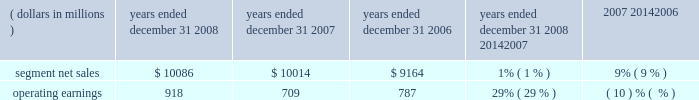Products and software , as well as ongoing investment in next-generation technologies , partially offset by savings from cost-reduction initiatives .
Reorganization of business charges increased due to employee severance costs and expenses related to the exit of a facility .
Sg&a expenses decreased , primarily due to lower marketing expenses and savings from cost-reduction initiatives , partially offset by increased expenditures on information technology upgrades .
As a percentage of net sales in 2007 as compared to 2006 , gross margin and operating margin decreased , and sg&a expenses and r&d expenditures increased .
The segment 2019s backlog was $ 647 million at december 31 , 2007 , compared to $ 1.4 billion at december 31 , 2006 .
This decrease in backlog was primarily due to a decline in customer demand driven by the segment 2019s limited product portfolio .
The segment shipped 159.1 million units in 2007 , a 27% ( 27 % ) decrease compared to shipments of 217.4 million units in 2006 .
The overall decrease reflects decreased unit shipments of products for all technologies .
For the full year 2007 , unit shipments : ( i ) decreased substantially in asia and emea , ( ii ) decreased in north america , and ( iii ) increased in latin america .
Although unit shipments by the segment decreased in 2007 , total unit shipments in the worldwide handset market increased by approximately 16% ( 16 % ) .
The segment estimates its worldwide market share was approximately 14% ( 14 % ) for the full year 2007 , a decrease of approximately 8 percentage points versus full year 2006 .
In 2007 , asp decreased approximately 9% ( 9 % ) compared to 2006 .
The overall decrease in asp was driven primarily by changes in the product-tier and geographic mix of sales .
By comparison , asp decreased approximately 11% ( 11 % ) in 2006 and 10% ( 10 % ) in 2005 .
The segment has several large customers located throughout the world .
In 2007 , aggregate net sales to the segment 2019s five largest customers accounted for approximately 42% ( 42 % ) of the segment 2019s net sales .
Besides selling directly to carriers and operators , the segment also sells products through a variety of third-party distributors and retailers , which account for approximately 33% ( 33 % ) of the segment 2019s net sales .
The largest of these distributors was brightstar corporation .
Although the u.s .
Market continued to be the segment 2019s largest individual market , many of our customers , and more than 54% ( 54 % ) of our segment 2019s 2007 net sales , were outside the u.s .
The largest of these international markets were brazil , china and mexico .
Home and networks mobility segment the home and networks mobility segment designs , manufactures , sells , installs and services : ( i ) digital video , internet protocol video and broadcast network interactive set-tops , end-to-end video delivery systems , broadband access infrastructure platforms , and associated data and voice customer premise equipment to cable television and telecom service providers ( collectively , referred to as the 201chome business 201d ) , and ( ii ) wireless access systems , including cellular infrastructure systems and wireless broadband systems , to wireless service providers ( collectively , referred to as the 201cnetwork business 201d ) .
In 2008 , the segment 2019s net sales represented 33% ( 33 % ) of the company 2019s consolidated net sales , compared to 27% ( 27 % ) in 2007 and 21% ( 21 % ) in 2006 .
( dollars in millions ) 2008 2007 2006 2008 20142007 2007 20142006 years ended december 31 percent change .
Segment results 20142008 compared to 2007 in 2008 , the segment 2019s net sales increased 1% ( 1 % ) to $ 10.1 billion , compared to $ 10.0 billion in 2007 .
The 1% ( 1 % ) increase in net sales primarily reflects a 16% ( 16 % ) increase in net sales in the home business , partially offset by an 11% ( 11 % ) decrease in net sales in the networks business .
The 16% ( 16 % ) increase in net sales in the home business is primarily driven by a 17% ( 17 % ) increase in net sales of digital entertainment devices , reflecting a 19% ( 19 % ) increase in unit shipments to 18.0 million units , partially offset by lower asp due to product mix shift and pricing pressure .
The 11% ( 11 % ) decrease in net sales in the networks business was primarily driven by : ( i ) the absence of net sales by the embedded communication computing group ( 201cecc 201d ) that was divested at the end of 2007 , and ( ii ) lower net sales of iden , gsm and cdma infrastructure equipment , partially offset by higher net sales of umts infrastructure equipment .
On a geographic basis , the 1% ( 1 % ) increase in net sales was primarily driven by higher net sales in latin america and asia , partially offset by lower net sales in north america .
The increase in net sales in latin america was 63management 2019s discussion and analysis of financial condition and results of operations %%transmsg*** transmitting job : c49054 pcn : 066000000 ***%%pcmsg|63 |00024|yes|no|02/24/2009 12:31|0|0|page is valid , no graphics -- color : n| .
What was the change in percentage of consolidated net sales from 2006 to 2008? 
Rationale: the consolidated net sales grew 72.95% from 2006 to 2008 . to get this answer you must find out the consolidated net sales which was given in line 23 . then you must take this consolidated net sales and subtract them from each other . take this answer and divide it by the consolidated net sales for 2006 .
Computations: (((10086 * 33%) - (9164 * 21%)) / (9164 * 21%))
Answer: 0.72953. 